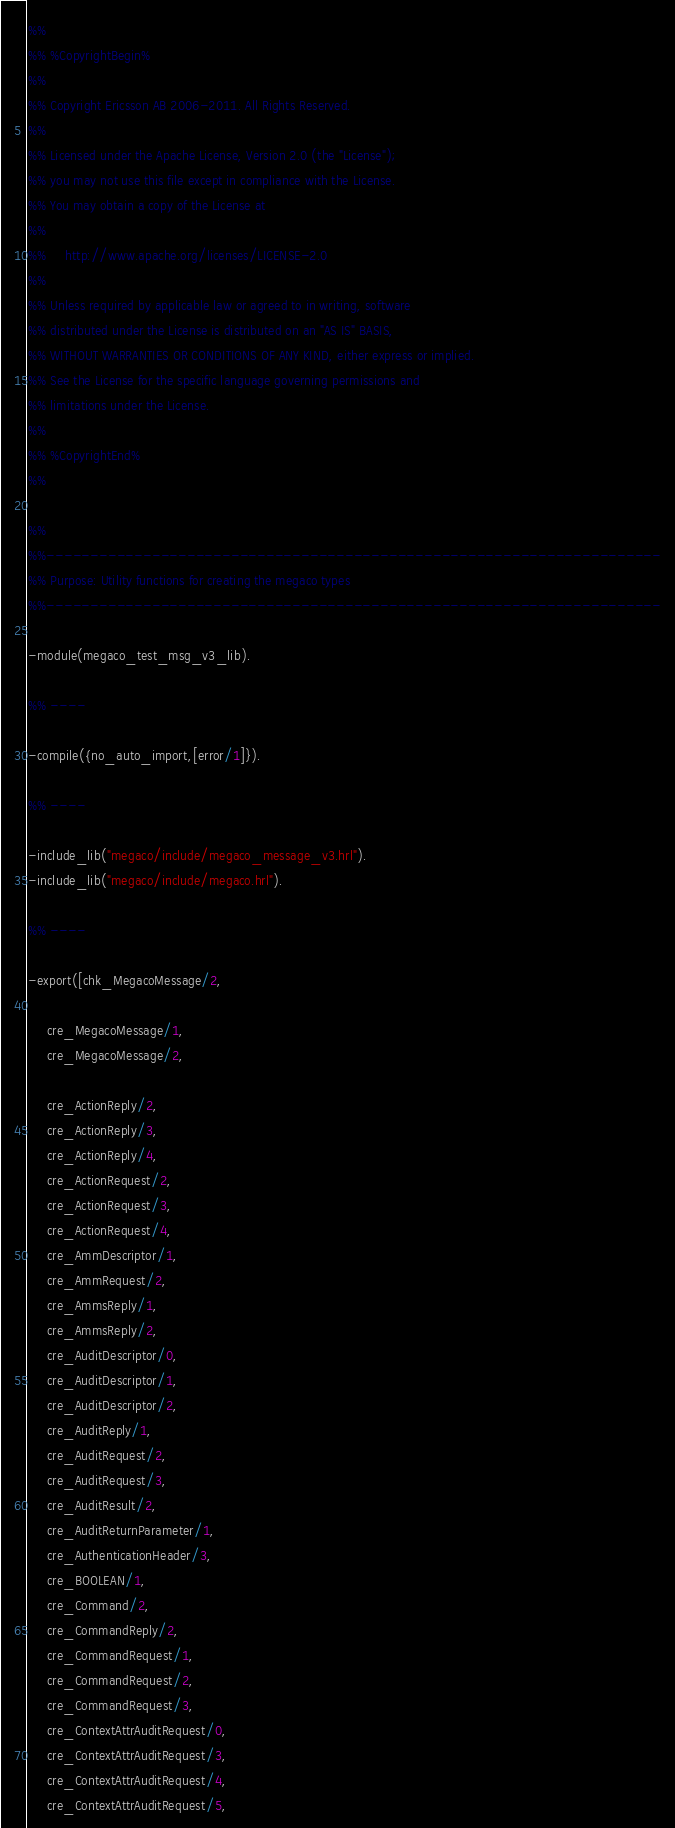<code> <loc_0><loc_0><loc_500><loc_500><_Erlang_>%%
%% %CopyrightBegin%
%% 
%% Copyright Ericsson AB 2006-2011. All Rights Reserved.
%% 
%% Licensed under the Apache License, Version 2.0 (the "License");
%% you may not use this file except in compliance with the License.
%% You may obtain a copy of the License at
%%
%%     http://www.apache.org/licenses/LICENSE-2.0
%%
%% Unless required by applicable law or agreed to in writing, software
%% distributed under the License is distributed on an "AS IS" BASIS,
%% WITHOUT WARRANTIES OR CONDITIONS OF ANY KIND, either express or implied.
%% See the License for the specific language governing permissions and
%% limitations under the License.
%% 
%% %CopyrightEnd%
%%

%%
%%----------------------------------------------------------------------
%% Purpose: Utility functions for creating the megaco types
%%----------------------------------------------------------------------

-module(megaco_test_msg_v3_lib).

%% ----

-compile({no_auto_import,[error/1]}).

%% ----

-include_lib("megaco/include/megaco_message_v3.hrl").
-include_lib("megaco/include/megaco.hrl").

%% ----

-export([chk_MegacoMessage/2,

	 cre_MegacoMessage/1, 
	 cre_MegacoMessage/2, 

	 cre_ActionReply/2, 
	 cre_ActionReply/3, 
	 cre_ActionReply/4, 
	 cre_ActionRequest/2, 
	 cre_ActionRequest/3, 
	 cre_ActionRequest/4, 
	 cre_AmmDescriptor/1, 
	 cre_AmmRequest/2, 
	 cre_AmmsReply/1, 
	 cre_AmmsReply/2, 
	 cre_AuditDescriptor/0, 
	 cre_AuditDescriptor/1, 
	 cre_AuditDescriptor/2, 
	 cre_AuditReply/1, 
	 cre_AuditRequest/2, 
	 cre_AuditRequest/3, 
	 cre_AuditResult/2, 
	 cre_AuditReturnParameter/1, 
	 cre_AuthenticationHeader/3,
	 cre_BOOLEAN/1, 
	 cre_Command/2, 
	 cre_CommandReply/2, 
	 cre_CommandRequest/1, 
	 cre_CommandRequest/2, 
	 cre_CommandRequest/3, 
	 cre_ContextAttrAuditRequest/0, 
	 cre_ContextAttrAuditRequest/3, 
	 cre_ContextAttrAuditRequest/4, 
	 cre_ContextAttrAuditRequest/5, </code> 